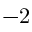Convert formula to latex. <formula><loc_0><loc_0><loc_500><loc_500>- 2</formula> 